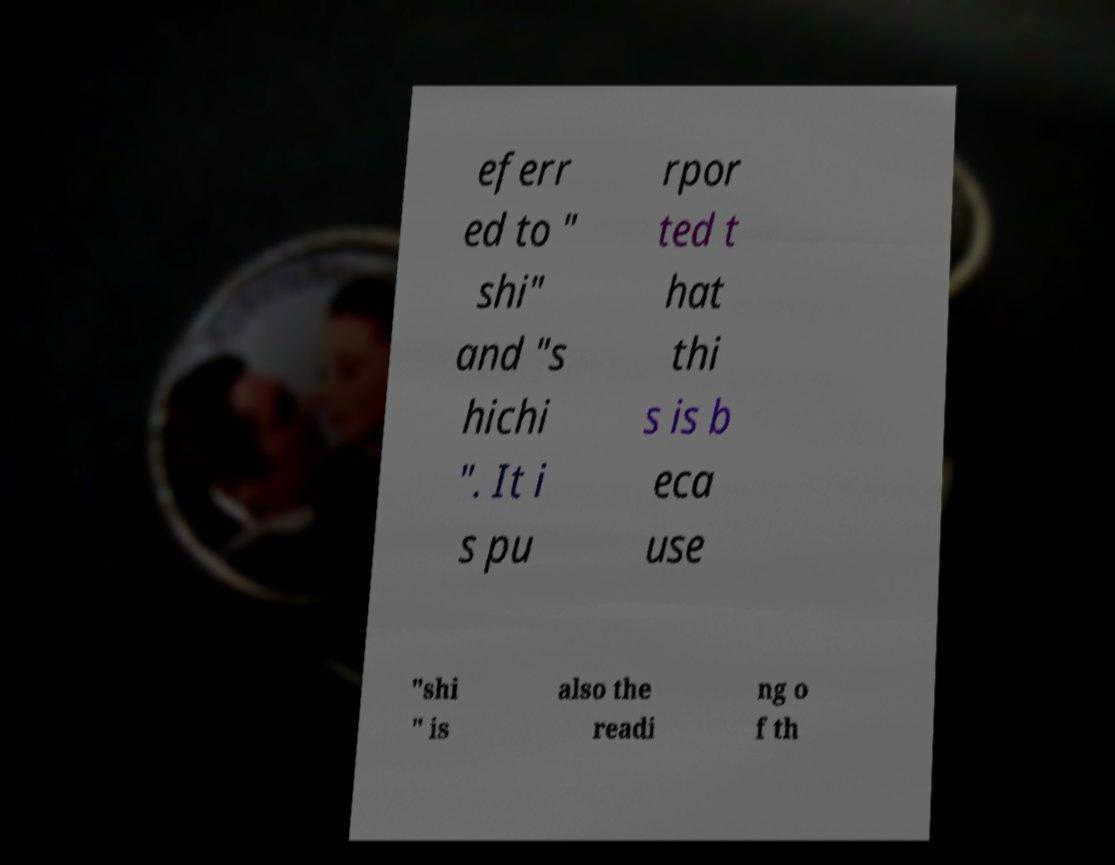There's text embedded in this image that I need extracted. Can you transcribe it verbatim? eferr ed to " shi" and "s hichi ". It i s pu rpor ted t hat thi s is b eca use "shi " is also the readi ng o f th 